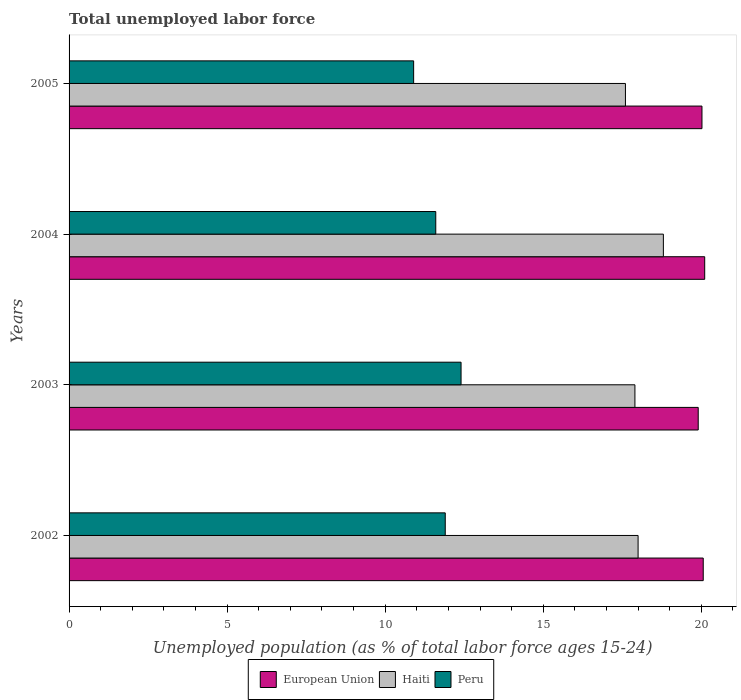How many different coloured bars are there?
Make the answer very short. 3. Are the number of bars per tick equal to the number of legend labels?
Give a very brief answer. Yes. Are the number of bars on each tick of the Y-axis equal?
Offer a very short reply. Yes. How many bars are there on the 3rd tick from the top?
Ensure brevity in your answer.  3. What is the label of the 1st group of bars from the top?
Your response must be concise. 2005. In how many cases, is the number of bars for a given year not equal to the number of legend labels?
Provide a short and direct response. 0. What is the percentage of unemployed population in in Peru in 2003?
Keep it short and to the point. 12.4. Across all years, what is the maximum percentage of unemployed population in in Peru?
Offer a very short reply. 12.4. Across all years, what is the minimum percentage of unemployed population in in European Union?
Keep it short and to the point. 19.9. In which year was the percentage of unemployed population in in European Union minimum?
Keep it short and to the point. 2003. What is the total percentage of unemployed population in in Haiti in the graph?
Offer a very short reply. 72.3. What is the difference between the percentage of unemployed population in in European Union in 2003 and that in 2005?
Provide a succinct answer. -0.12. What is the difference between the percentage of unemployed population in in Haiti in 2004 and the percentage of unemployed population in in European Union in 2003?
Offer a terse response. -1.1. What is the average percentage of unemployed population in in European Union per year?
Ensure brevity in your answer.  20.02. In the year 2005, what is the difference between the percentage of unemployed population in in European Union and percentage of unemployed population in in Haiti?
Your answer should be compact. 2.42. What is the ratio of the percentage of unemployed population in in European Union in 2002 to that in 2004?
Give a very brief answer. 1. Is the percentage of unemployed population in in Peru in 2002 less than that in 2005?
Give a very brief answer. No. What is the difference between the highest and the lowest percentage of unemployed population in in Peru?
Your answer should be very brief. 1.5. What does the 2nd bar from the top in 2004 represents?
Make the answer very short. Haiti. What does the 1st bar from the bottom in 2002 represents?
Your response must be concise. European Union. Are all the bars in the graph horizontal?
Your response must be concise. Yes. What is the difference between two consecutive major ticks on the X-axis?
Offer a terse response. 5. Are the values on the major ticks of X-axis written in scientific E-notation?
Provide a short and direct response. No. Does the graph contain any zero values?
Your response must be concise. No. Where does the legend appear in the graph?
Offer a terse response. Bottom center. What is the title of the graph?
Give a very brief answer. Total unemployed labor force. Does "Sao Tome and Principe" appear as one of the legend labels in the graph?
Keep it short and to the point. No. What is the label or title of the X-axis?
Offer a very short reply. Unemployed population (as % of total labor force ages 15-24). What is the label or title of the Y-axis?
Your answer should be very brief. Years. What is the Unemployed population (as % of total labor force ages 15-24) in European Union in 2002?
Make the answer very short. 20.06. What is the Unemployed population (as % of total labor force ages 15-24) in Peru in 2002?
Make the answer very short. 11.9. What is the Unemployed population (as % of total labor force ages 15-24) of European Union in 2003?
Ensure brevity in your answer.  19.9. What is the Unemployed population (as % of total labor force ages 15-24) of Haiti in 2003?
Make the answer very short. 17.9. What is the Unemployed population (as % of total labor force ages 15-24) in Peru in 2003?
Ensure brevity in your answer.  12.4. What is the Unemployed population (as % of total labor force ages 15-24) of European Union in 2004?
Ensure brevity in your answer.  20.11. What is the Unemployed population (as % of total labor force ages 15-24) in Haiti in 2004?
Your answer should be very brief. 18.8. What is the Unemployed population (as % of total labor force ages 15-24) of Peru in 2004?
Ensure brevity in your answer.  11.6. What is the Unemployed population (as % of total labor force ages 15-24) of European Union in 2005?
Ensure brevity in your answer.  20.02. What is the Unemployed population (as % of total labor force ages 15-24) in Haiti in 2005?
Provide a short and direct response. 17.6. What is the Unemployed population (as % of total labor force ages 15-24) of Peru in 2005?
Your answer should be very brief. 10.9. Across all years, what is the maximum Unemployed population (as % of total labor force ages 15-24) of European Union?
Give a very brief answer. 20.11. Across all years, what is the maximum Unemployed population (as % of total labor force ages 15-24) in Haiti?
Provide a short and direct response. 18.8. Across all years, what is the maximum Unemployed population (as % of total labor force ages 15-24) of Peru?
Make the answer very short. 12.4. Across all years, what is the minimum Unemployed population (as % of total labor force ages 15-24) of European Union?
Your answer should be compact. 19.9. Across all years, what is the minimum Unemployed population (as % of total labor force ages 15-24) of Haiti?
Keep it short and to the point. 17.6. Across all years, what is the minimum Unemployed population (as % of total labor force ages 15-24) of Peru?
Make the answer very short. 10.9. What is the total Unemployed population (as % of total labor force ages 15-24) in European Union in the graph?
Offer a very short reply. 80.09. What is the total Unemployed population (as % of total labor force ages 15-24) of Haiti in the graph?
Provide a short and direct response. 72.3. What is the total Unemployed population (as % of total labor force ages 15-24) in Peru in the graph?
Keep it short and to the point. 46.8. What is the difference between the Unemployed population (as % of total labor force ages 15-24) of European Union in 2002 and that in 2003?
Provide a short and direct response. 0.16. What is the difference between the Unemployed population (as % of total labor force ages 15-24) of Haiti in 2002 and that in 2003?
Offer a terse response. 0.1. What is the difference between the Unemployed population (as % of total labor force ages 15-24) of European Union in 2002 and that in 2004?
Your answer should be compact. -0.05. What is the difference between the Unemployed population (as % of total labor force ages 15-24) of Peru in 2002 and that in 2004?
Your answer should be compact. 0.3. What is the difference between the Unemployed population (as % of total labor force ages 15-24) in Haiti in 2002 and that in 2005?
Your answer should be compact. 0.4. What is the difference between the Unemployed population (as % of total labor force ages 15-24) of European Union in 2003 and that in 2004?
Ensure brevity in your answer.  -0.21. What is the difference between the Unemployed population (as % of total labor force ages 15-24) of Peru in 2003 and that in 2004?
Make the answer very short. 0.8. What is the difference between the Unemployed population (as % of total labor force ages 15-24) of European Union in 2003 and that in 2005?
Offer a terse response. -0.12. What is the difference between the Unemployed population (as % of total labor force ages 15-24) of Peru in 2003 and that in 2005?
Offer a terse response. 1.5. What is the difference between the Unemployed population (as % of total labor force ages 15-24) in European Union in 2004 and that in 2005?
Provide a short and direct response. 0.09. What is the difference between the Unemployed population (as % of total labor force ages 15-24) of Haiti in 2004 and that in 2005?
Offer a very short reply. 1.2. What is the difference between the Unemployed population (as % of total labor force ages 15-24) in European Union in 2002 and the Unemployed population (as % of total labor force ages 15-24) in Haiti in 2003?
Ensure brevity in your answer.  2.16. What is the difference between the Unemployed population (as % of total labor force ages 15-24) of European Union in 2002 and the Unemployed population (as % of total labor force ages 15-24) of Peru in 2003?
Your answer should be compact. 7.66. What is the difference between the Unemployed population (as % of total labor force ages 15-24) in European Union in 2002 and the Unemployed population (as % of total labor force ages 15-24) in Haiti in 2004?
Ensure brevity in your answer.  1.26. What is the difference between the Unemployed population (as % of total labor force ages 15-24) of European Union in 2002 and the Unemployed population (as % of total labor force ages 15-24) of Peru in 2004?
Offer a very short reply. 8.46. What is the difference between the Unemployed population (as % of total labor force ages 15-24) in European Union in 2002 and the Unemployed population (as % of total labor force ages 15-24) in Haiti in 2005?
Provide a short and direct response. 2.46. What is the difference between the Unemployed population (as % of total labor force ages 15-24) in European Union in 2002 and the Unemployed population (as % of total labor force ages 15-24) in Peru in 2005?
Your answer should be very brief. 9.16. What is the difference between the Unemployed population (as % of total labor force ages 15-24) of European Union in 2003 and the Unemployed population (as % of total labor force ages 15-24) of Haiti in 2004?
Provide a short and direct response. 1.1. What is the difference between the Unemployed population (as % of total labor force ages 15-24) in European Union in 2003 and the Unemployed population (as % of total labor force ages 15-24) in Peru in 2004?
Your answer should be compact. 8.3. What is the difference between the Unemployed population (as % of total labor force ages 15-24) of European Union in 2003 and the Unemployed population (as % of total labor force ages 15-24) of Haiti in 2005?
Give a very brief answer. 2.3. What is the difference between the Unemployed population (as % of total labor force ages 15-24) of European Union in 2003 and the Unemployed population (as % of total labor force ages 15-24) of Peru in 2005?
Provide a succinct answer. 9. What is the difference between the Unemployed population (as % of total labor force ages 15-24) in Haiti in 2003 and the Unemployed population (as % of total labor force ages 15-24) in Peru in 2005?
Your answer should be compact. 7. What is the difference between the Unemployed population (as % of total labor force ages 15-24) of European Union in 2004 and the Unemployed population (as % of total labor force ages 15-24) of Haiti in 2005?
Provide a succinct answer. 2.51. What is the difference between the Unemployed population (as % of total labor force ages 15-24) in European Union in 2004 and the Unemployed population (as % of total labor force ages 15-24) in Peru in 2005?
Give a very brief answer. 9.21. What is the average Unemployed population (as % of total labor force ages 15-24) of European Union per year?
Offer a terse response. 20.02. What is the average Unemployed population (as % of total labor force ages 15-24) of Haiti per year?
Ensure brevity in your answer.  18.07. What is the average Unemployed population (as % of total labor force ages 15-24) of Peru per year?
Give a very brief answer. 11.7. In the year 2002, what is the difference between the Unemployed population (as % of total labor force ages 15-24) of European Union and Unemployed population (as % of total labor force ages 15-24) of Haiti?
Give a very brief answer. 2.06. In the year 2002, what is the difference between the Unemployed population (as % of total labor force ages 15-24) in European Union and Unemployed population (as % of total labor force ages 15-24) in Peru?
Provide a short and direct response. 8.16. In the year 2002, what is the difference between the Unemployed population (as % of total labor force ages 15-24) of Haiti and Unemployed population (as % of total labor force ages 15-24) of Peru?
Offer a very short reply. 6.1. In the year 2003, what is the difference between the Unemployed population (as % of total labor force ages 15-24) in European Union and Unemployed population (as % of total labor force ages 15-24) in Haiti?
Provide a succinct answer. 2. In the year 2003, what is the difference between the Unemployed population (as % of total labor force ages 15-24) of European Union and Unemployed population (as % of total labor force ages 15-24) of Peru?
Keep it short and to the point. 7.5. In the year 2003, what is the difference between the Unemployed population (as % of total labor force ages 15-24) of Haiti and Unemployed population (as % of total labor force ages 15-24) of Peru?
Ensure brevity in your answer.  5.5. In the year 2004, what is the difference between the Unemployed population (as % of total labor force ages 15-24) in European Union and Unemployed population (as % of total labor force ages 15-24) in Haiti?
Give a very brief answer. 1.31. In the year 2004, what is the difference between the Unemployed population (as % of total labor force ages 15-24) in European Union and Unemployed population (as % of total labor force ages 15-24) in Peru?
Keep it short and to the point. 8.51. In the year 2005, what is the difference between the Unemployed population (as % of total labor force ages 15-24) of European Union and Unemployed population (as % of total labor force ages 15-24) of Haiti?
Offer a terse response. 2.42. In the year 2005, what is the difference between the Unemployed population (as % of total labor force ages 15-24) of European Union and Unemployed population (as % of total labor force ages 15-24) of Peru?
Offer a very short reply. 9.12. What is the ratio of the Unemployed population (as % of total labor force ages 15-24) in European Union in 2002 to that in 2003?
Provide a short and direct response. 1.01. What is the ratio of the Unemployed population (as % of total labor force ages 15-24) of Haiti in 2002 to that in 2003?
Provide a succinct answer. 1.01. What is the ratio of the Unemployed population (as % of total labor force ages 15-24) in Peru in 2002 to that in 2003?
Provide a short and direct response. 0.96. What is the ratio of the Unemployed population (as % of total labor force ages 15-24) of European Union in 2002 to that in 2004?
Make the answer very short. 1. What is the ratio of the Unemployed population (as % of total labor force ages 15-24) in Haiti in 2002 to that in 2004?
Your answer should be very brief. 0.96. What is the ratio of the Unemployed population (as % of total labor force ages 15-24) in Peru in 2002 to that in 2004?
Your answer should be very brief. 1.03. What is the ratio of the Unemployed population (as % of total labor force ages 15-24) of European Union in 2002 to that in 2005?
Make the answer very short. 1. What is the ratio of the Unemployed population (as % of total labor force ages 15-24) in Haiti in 2002 to that in 2005?
Ensure brevity in your answer.  1.02. What is the ratio of the Unemployed population (as % of total labor force ages 15-24) of Peru in 2002 to that in 2005?
Ensure brevity in your answer.  1.09. What is the ratio of the Unemployed population (as % of total labor force ages 15-24) in Haiti in 2003 to that in 2004?
Your answer should be very brief. 0.95. What is the ratio of the Unemployed population (as % of total labor force ages 15-24) in Peru in 2003 to that in 2004?
Your answer should be compact. 1.07. What is the ratio of the Unemployed population (as % of total labor force ages 15-24) of European Union in 2003 to that in 2005?
Offer a very short reply. 0.99. What is the ratio of the Unemployed population (as % of total labor force ages 15-24) in Peru in 2003 to that in 2005?
Your answer should be very brief. 1.14. What is the ratio of the Unemployed population (as % of total labor force ages 15-24) of Haiti in 2004 to that in 2005?
Provide a succinct answer. 1.07. What is the ratio of the Unemployed population (as % of total labor force ages 15-24) of Peru in 2004 to that in 2005?
Provide a succinct answer. 1.06. What is the difference between the highest and the second highest Unemployed population (as % of total labor force ages 15-24) of European Union?
Ensure brevity in your answer.  0.05. What is the difference between the highest and the second highest Unemployed population (as % of total labor force ages 15-24) in Haiti?
Offer a terse response. 0.8. What is the difference between the highest and the second highest Unemployed population (as % of total labor force ages 15-24) in Peru?
Offer a very short reply. 0.5. What is the difference between the highest and the lowest Unemployed population (as % of total labor force ages 15-24) of European Union?
Your answer should be very brief. 0.21. What is the difference between the highest and the lowest Unemployed population (as % of total labor force ages 15-24) in Haiti?
Keep it short and to the point. 1.2. 